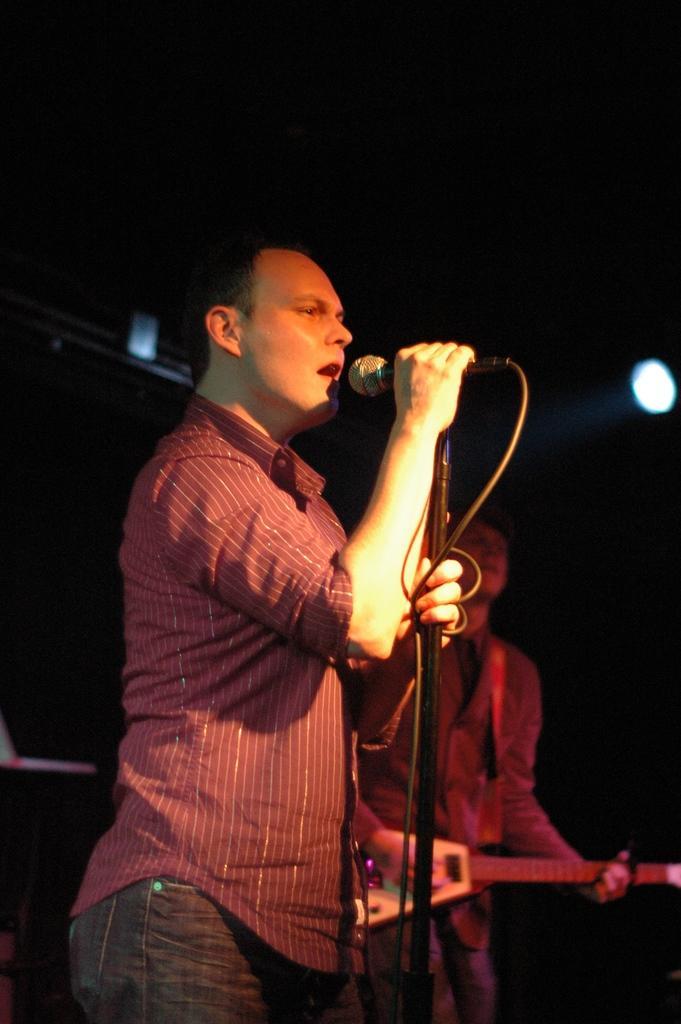Describe this image in one or two sentences. Here in this picture a man with red shirt and a jeans pant. He is holding the mic and he is singing. To the left of him there is man playing guitar. 